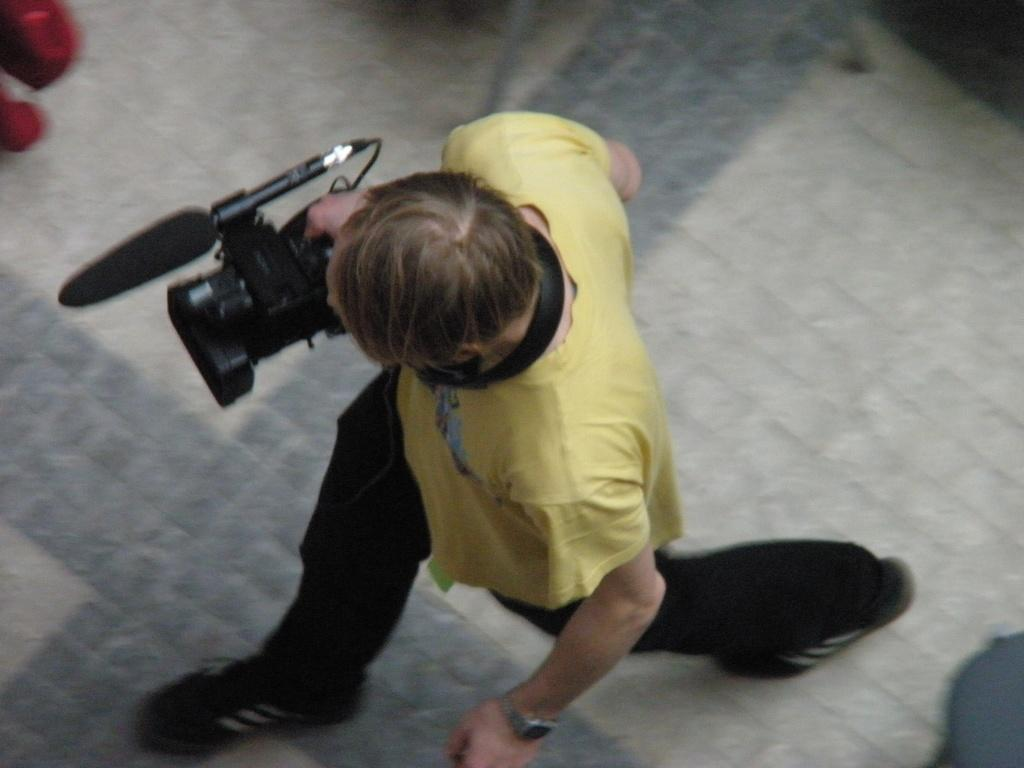What is the main subject of the image? There is a person in the image. What is the person doing in the image? The person is walking on the floor. What is the person wearing in the image? The person is wearing a yellow t-shirt. What object is the person holding in the image? The person is holding a camera. How many scarves is the person wearing in the image? There is no scarf present in the image. What form does the camera take in the image? The camera is a handheld device, not a specific form. 